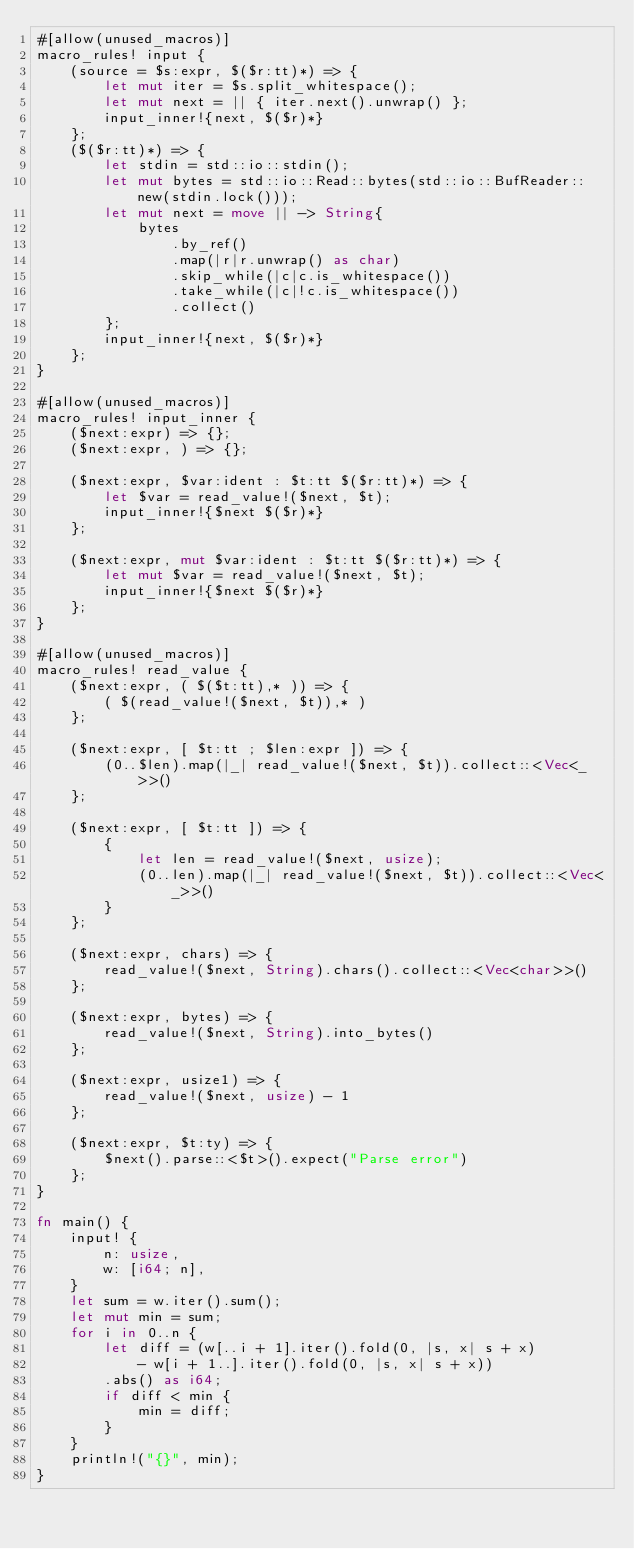Convert code to text. <code><loc_0><loc_0><loc_500><loc_500><_Rust_>#[allow(unused_macros)]
macro_rules! input {
    (source = $s:expr, $($r:tt)*) => {
        let mut iter = $s.split_whitespace();
        let mut next = || { iter.next().unwrap() };
        input_inner!{next, $($r)*}
    };
    ($($r:tt)*) => {
        let stdin = std::io::stdin();
        let mut bytes = std::io::Read::bytes(std::io::BufReader::new(stdin.lock()));
        let mut next = move || -> String{
            bytes
                .by_ref()
                .map(|r|r.unwrap() as char)
                .skip_while(|c|c.is_whitespace())
                .take_while(|c|!c.is_whitespace())
                .collect()
        };
        input_inner!{next, $($r)*}
    };
}

#[allow(unused_macros)]
macro_rules! input_inner {
    ($next:expr) => {};
    ($next:expr, ) => {};

    ($next:expr, $var:ident : $t:tt $($r:tt)*) => {
        let $var = read_value!($next, $t);
        input_inner!{$next $($r)*}
    };

    ($next:expr, mut $var:ident : $t:tt $($r:tt)*) => {
        let mut $var = read_value!($next, $t);
        input_inner!{$next $($r)*}
    };
}

#[allow(unused_macros)]
macro_rules! read_value {
    ($next:expr, ( $($t:tt),* )) => {
        ( $(read_value!($next, $t)),* )
    };

    ($next:expr, [ $t:tt ; $len:expr ]) => {
        (0..$len).map(|_| read_value!($next, $t)).collect::<Vec<_>>()
    };

    ($next:expr, [ $t:tt ]) => {
        {
            let len = read_value!($next, usize);
            (0..len).map(|_| read_value!($next, $t)).collect::<Vec<_>>()
        }
    };

    ($next:expr, chars) => {
        read_value!($next, String).chars().collect::<Vec<char>>()
    };

    ($next:expr, bytes) => {
        read_value!($next, String).into_bytes()
    };

    ($next:expr, usize1) => {
        read_value!($next, usize) - 1
    };

    ($next:expr, $t:ty) => {
        $next().parse::<$t>().expect("Parse error")
    };
}

fn main() {
    input! {
        n: usize,
        w: [i64; n],
    }
    let sum = w.iter().sum();
    let mut min = sum;
    for i in 0..n {
        let diff = (w[..i + 1].iter().fold(0, |s, x| s + x)
            - w[i + 1..].iter().fold(0, |s, x| s + x))
        .abs() as i64;
        if diff < min {
            min = diff;
        }
    }
    println!("{}", min);
}
</code> 